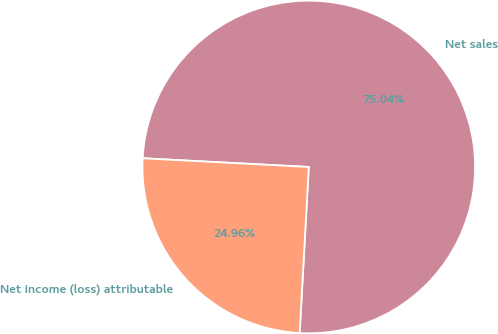<chart> <loc_0><loc_0><loc_500><loc_500><pie_chart><fcel>Net sales<fcel>Net income (loss) attributable<nl><fcel>75.04%<fcel>24.96%<nl></chart> 